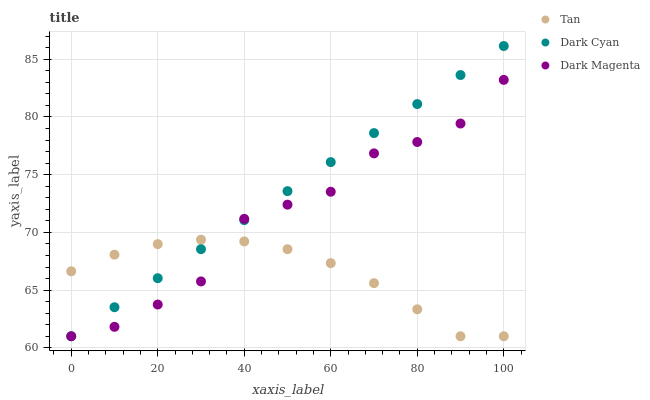Does Tan have the minimum area under the curve?
Answer yes or no. Yes. Does Dark Cyan have the maximum area under the curve?
Answer yes or no. Yes. Does Dark Magenta have the minimum area under the curve?
Answer yes or no. No. Does Dark Magenta have the maximum area under the curve?
Answer yes or no. No. Is Dark Cyan the smoothest?
Answer yes or no. Yes. Is Dark Magenta the roughest?
Answer yes or no. Yes. Is Tan the smoothest?
Answer yes or no. No. Is Tan the roughest?
Answer yes or no. No. Does Dark Cyan have the lowest value?
Answer yes or no. Yes. Does Dark Cyan have the highest value?
Answer yes or no. Yes. Does Dark Magenta have the highest value?
Answer yes or no. No. Does Tan intersect Dark Cyan?
Answer yes or no. Yes. Is Tan less than Dark Cyan?
Answer yes or no. No. Is Tan greater than Dark Cyan?
Answer yes or no. No. 